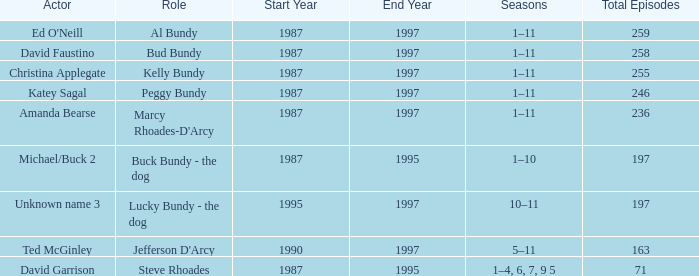How many episodes did the actor David Faustino appear in? 258.0. Could you parse the entire table? {'header': ['Actor', 'Role', 'Start Year', 'End Year', 'Seasons', 'Total Episodes'], 'rows': [["Ed O'Neill", 'Al Bundy', '1987', '1997', '1–11', '259'], ['David Faustino', 'Bud Bundy', '1987', '1997', '1–11', '258'], ['Christina Applegate', 'Kelly Bundy', '1987', '1997', '1–11', '255'], ['Katey Sagal', 'Peggy Bundy', '1987', '1997', '1–11', '246'], ['Amanda Bearse', "Marcy Rhoades-D'Arcy", '1987', '1997', '1–11', '236'], ['Michael/Buck 2', 'Buck Bundy - the dog', '1987', '1995', '1–10', '197'], ['Unknown name 3', 'Lucky Bundy - the dog', '1995', '1997', '10–11', '197'], ['Ted McGinley', "Jefferson D'Arcy", '1990', '1997', '5–11', '163'], ['David Garrison', 'Steve Rhoades', '1987', '1995', '1–4, 6, 7, 9 5', '71']]} 